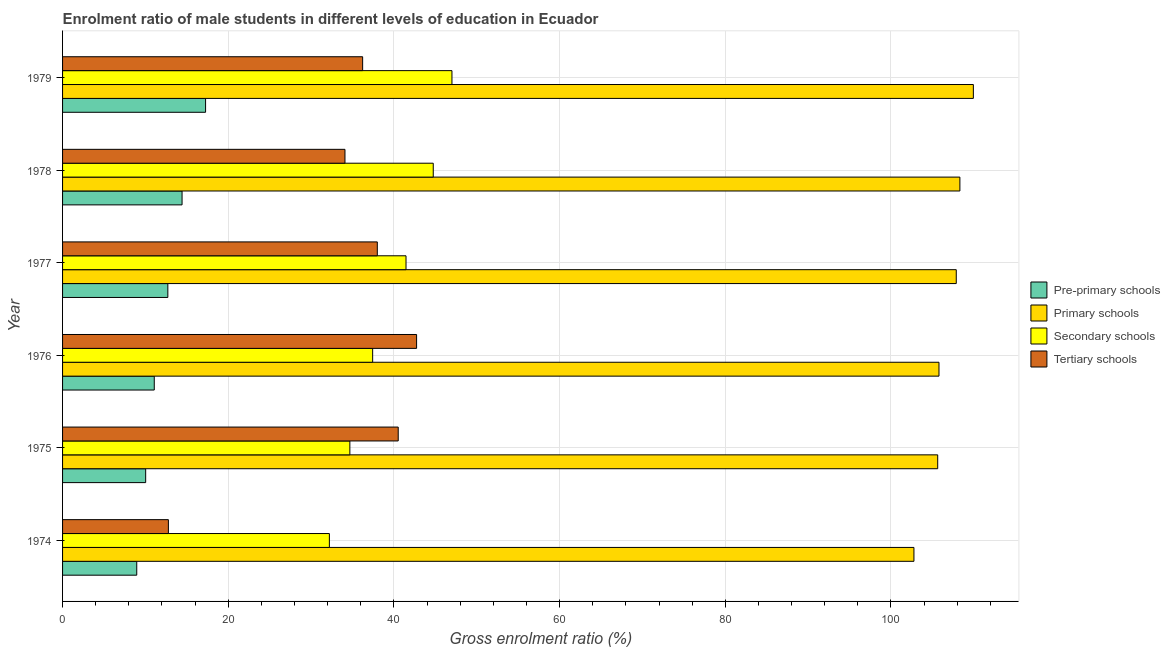How many different coloured bars are there?
Give a very brief answer. 4. How many groups of bars are there?
Provide a succinct answer. 6. Are the number of bars on each tick of the Y-axis equal?
Make the answer very short. Yes. How many bars are there on the 4th tick from the top?
Offer a terse response. 4. How many bars are there on the 6th tick from the bottom?
Your response must be concise. 4. What is the label of the 3rd group of bars from the top?
Keep it short and to the point. 1977. What is the gross enrolment ratio(female) in primary schools in 1976?
Offer a terse response. 105.8. Across all years, what is the maximum gross enrolment ratio(female) in pre-primary schools?
Provide a short and direct response. 17.27. Across all years, what is the minimum gross enrolment ratio(female) in pre-primary schools?
Make the answer very short. 8.96. In which year was the gross enrolment ratio(female) in tertiary schools maximum?
Offer a terse response. 1976. In which year was the gross enrolment ratio(female) in pre-primary schools minimum?
Provide a succinct answer. 1974. What is the total gross enrolment ratio(female) in tertiary schools in the graph?
Your answer should be very brief. 204.34. What is the difference between the gross enrolment ratio(female) in tertiary schools in 1975 and that in 1976?
Offer a terse response. -2.22. What is the difference between the gross enrolment ratio(female) in primary schools in 1978 and the gross enrolment ratio(female) in pre-primary schools in 1975?
Give a very brief answer. 98.29. What is the average gross enrolment ratio(female) in pre-primary schools per year?
Provide a succinct answer. 12.41. In the year 1974, what is the difference between the gross enrolment ratio(female) in tertiary schools and gross enrolment ratio(female) in secondary schools?
Your answer should be compact. -19.43. What is the ratio of the gross enrolment ratio(female) in tertiary schools in 1977 to that in 1978?
Give a very brief answer. 1.11. Is the difference between the gross enrolment ratio(female) in primary schools in 1977 and 1979 greater than the difference between the gross enrolment ratio(female) in tertiary schools in 1977 and 1979?
Your answer should be compact. No. What is the difference between the highest and the second highest gross enrolment ratio(female) in tertiary schools?
Make the answer very short. 2.22. What is the difference between the highest and the lowest gross enrolment ratio(female) in tertiary schools?
Your answer should be compact. 29.96. Is the sum of the gross enrolment ratio(female) in secondary schools in 1975 and 1978 greater than the maximum gross enrolment ratio(female) in pre-primary schools across all years?
Your response must be concise. Yes. What does the 2nd bar from the top in 1979 represents?
Provide a succinct answer. Secondary schools. What does the 2nd bar from the bottom in 1978 represents?
Give a very brief answer. Primary schools. Is it the case that in every year, the sum of the gross enrolment ratio(female) in pre-primary schools and gross enrolment ratio(female) in primary schools is greater than the gross enrolment ratio(female) in secondary schools?
Ensure brevity in your answer.  Yes. What is the difference between two consecutive major ticks on the X-axis?
Ensure brevity in your answer.  20. Are the values on the major ticks of X-axis written in scientific E-notation?
Offer a terse response. No. Where does the legend appear in the graph?
Provide a short and direct response. Center right. How many legend labels are there?
Your response must be concise. 4. How are the legend labels stacked?
Make the answer very short. Vertical. What is the title of the graph?
Offer a terse response. Enrolment ratio of male students in different levels of education in Ecuador. What is the label or title of the Y-axis?
Your answer should be compact. Year. What is the Gross enrolment ratio (%) in Pre-primary schools in 1974?
Your answer should be very brief. 8.96. What is the Gross enrolment ratio (%) of Primary schools in 1974?
Provide a succinct answer. 102.78. What is the Gross enrolment ratio (%) in Secondary schools in 1974?
Your answer should be very brief. 32.21. What is the Gross enrolment ratio (%) of Tertiary schools in 1974?
Keep it short and to the point. 12.77. What is the Gross enrolment ratio (%) in Pre-primary schools in 1975?
Make the answer very short. 10.03. What is the Gross enrolment ratio (%) of Primary schools in 1975?
Give a very brief answer. 105.65. What is the Gross enrolment ratio (%) of Secondary schools in 1975?
Give a very brief answer. 34.68. What is the Gross enrolment ratio (%) of Tertiary schools in 1975?
Offer a terse response. 40.52. What is the Gross enrolment ratio (%) of Pre-primary schools in 1976?
Make the answer very short. 11.07. What is the Gross enrolment ratio (%) of Primary schools in 1976?
Give a very brief answer. 105.8. What is the Gross enrolment ratio (%) in Secondary schools in 1976?
Provide a short and direct response. 37.43. What is the Gross enrolment ratio (%) in Tertiary schools in 1976?
Your response must be concise. 42.74. What is the Gross enrolment ratio (%) in Pre-primary schools in 1977?
Make the answer very short. 12.71. What is the Gross enrolment ratio (%) of Primary schools in 1977?
Offer a terse response. 107.89. What is the Gross enrolment ratio (%) of Secondary schools in 1977?
Make the answer very short. 41.46. What is the Gross enrolment ratio (%) in Tertiary schools in 1977?
Your answer should be very brief. 38. What is the Gross enrolment ratio (%) in Pre-primary schools in 1978?
Provide a succinct answer. 14.43. What is the Gross enrolment ratio (%) in Primary schools in 1978?
Give a very brief answer. 108.32. What is the Gross enrolment ratio (%) of Secondary schools in 1978?
Your answer should be compact. 44.75. What is the Gross enrolment ratio (%) of Tertiary schools in 1978?
Provide a succinct answer. 34.09. What is the Gross enrolment ratio (%) in Pre-primary schools in 1979?
Your answer should be very brief. 17.27. What is the Gross enrolment ratio (%) in Primary schools in 1979?
Give a very brief answer. 109.95. What is the Gross enrolment ratio (%) of Secondary schools in 1979?
Offer a very short reply. 47.01. What is the Gross enrolment ratio (%) of Tertiary schools in 1979?
Your answer should be compact. 36.22. Across all years, what is the maximum Gross enrolment ratio (%) in Pre-primary schools?
Your response must be concise. 17.27. Across all years, what is the maximum Gross enrolment ratio (%) of Primary schools?
Offer a terse response. 109.95. Across all years, what is the maximum Gross enrolment ratio (%) in Secondary schools?
Give a very brief answer. 47.01. Across all years, what is the maximum Gross enrolment ratio (%) in Tertiary schools?
Offer a very short reply. 42.74. Across all years, what is the minimum Gross enrolment ratio (%) of Pre-primary schools?
Make the answer very short. 8.96. Across all years, what is the minimum Gross enrolment ratio (%) in Primary schools?
Provide a succinct answer. 102.78. Across all years, what is the minimum Gross enrolment ratio (%) of Secondary schools?
Keep it short and to the point. 32.21. Across all years, what is the minimum Gross enrolment ratio (%) in Tertiary schools?
Your answer should be compact. 12.77. What is the total Gross enrolment ratio (%) of Pre-primary schools in the graph?
Provide a short and direct response. 74.46. What is the total Gross enrolment ratio (%) of Primary schools in the graph?
Make the answer very short. 640.38. What is the total Gross enrolment ratio (%) in Secondary schools in the graph?
Give a very brief answer. 237.54. What is the total Gross enrolment ratio (%) of Tertiary schools in the graph?
Give a very brief answer. 204.34. What is the difference between the Gross enrolment ratio (%) in Pre-primary schools in 1974 and that in 1975?
Make the answer very short. -1.08. What is the difference between the Gross enrolment ratio (%) in Primary schools in 1974 and that in 1975?
Provide a succinct answer. -2.87. What is the difference between the Gross enrolment ratio (%) in Secondary schools in 1974 and that in 1975?
Make the answer very short. -2.47. What is the difference between the Gross enrolment ratio (%) of Tertiary schools in 1974 and that in 1975?
Ensure brevity in your answer.  -27.75. What is the difference between the Gross enrolment ratio (%) in Pre-primary schools in 1974 and that in 1976?
Ensure brevity in your answer.  -2.11. What is the difference between the Gross enrolment ratio (%) of Primary schools in 1974 and that in 1976?
Your answer should be compact. -3.02. What is the difference between the Gross enrolment ratio (%) in Secondary schools in 1974 and that in 1976?
Provide a short and direct response. -5.22. What is the difference between the Gross enrolment ratio (%) in Tertiary schools in 1974 and that in 1976?
Make the answer very short. -29.96. What is the difference between the Gross enrolment ratio (%) in Pre-primary schools in 1974 and that in 1977?
Provide a succinct answer. -3.75. What is the difference between the Gross enrolment ratio (%) of Primary schools in 1974 and that in 1977?
Keep it short and to the point. -5.11. What is the difference between the Gross enrolment ratio (%) in Secondary schools in 1974 and that in 1977?
Your answer should be very brief. -9.25. What is the difference between the Gross enrolment ratio (%) in Tertiary schools in 1974 and that in 1977?
Offer a very short reply. -25.22. What is the difference between the Gross enrolment ratio (%) of Pre-primary schools in 1974 and that in 1978?
Offer a terse response. -5.47. What is the difference between the Gross enrolment ratio (%) in Primary schools in 1974 and that in 1978?
Offer a terse response. -5.55. What is the difference between the Gross enrolment ratio (%) in Secondary schools in 1974 and that in 1978?
Provide a short and direct response. -12.54. What is the difference between the Gross enrolment ratio (%) in Tertiary schools in 1974 and that in 1978?
Provide a succinct answer. -21.32. What is the difference between the Gross enrolment ratio (%) in Pre-primary schools in 1974 and that in 1979?
Your answer should be compact. -8.31. What is the difference between the Gross enrolment ratio (%) in Primary schools in 1974 and that in 1979?
Provide a succinct answer. -7.17. What is the difference between the Gross enrolment ratio (%) in Secondary schools in 1974 and that in 1979?
Keep it short and to the point. -14.8. What is the difference between the Gross enrolment ratio (%) in Tertiary schools in 1974 and that in 1979?
Make the answer very short. -23.45. What is the difference between the Gross enrolment ratio (%) in Pre-primary schools in 1975 and that in 1976?
Offer a very short reply. -1.04. What is the difference between the Gross enrolment ratio (%) in Primary schools in 1975 and that in 1976?
Your answer should be very brief. -0.15. What is the difference between the Gross enrolment ratio (%) of Secondary schools in 1975 and that in 1976?
Ensure brevity in your answer.  -2.75. What is the difference between the Gross enrolment ratio (%) in Tertiary schools in 1975 and that in 1976?
Offer a very short reply. -2.22. What is the difference between the Gross enrolment ratio (%) in Pre-primary schools in 1975 and that in 1977?
Make the answer very short. -2.68. What is the difference between the Gross enrolment ratio (%) in Primary schools in 1975 and that in 1977?
Your answer should be compact. -2.24. What is the difference between the Gross enrolment ratio (%) of Secondary schools in 1975 and that in 1977?
Offer a very short reply. -6.78. What is the difference between the Gross enrolment ratio (%) in Tertiary schools in 1975 and that in 1977?
Make the answer very short. 2.52. What is the difference between the Gross enrolment ratio (%) of Pre-primary schools in 1975 and that in 1978?
Your response must be concise. -4.39. What is the difference between the Gross enrolment ratio (%) in Primary schools in 1975 and that in 1978?
Your answer should be compact. -2.68. What is the difference between the Gross enrolment ratio (%) in Secondary schools in 1975 and that in 1978?
Provide a short and direct response. -10.07. What is the difference between the Gross enrolment ratio (%) in Tertiary schools in 1975 and that in 1978?
Ensure brevity in your answer.  6.43. What is the difference between the Gross enrolment ratio (%) in Pre-primary schools in 1975 and that in 1979?
Keep it short and to the point. -7.23. What is the difference between the Gross enrolment ratio (%) in Primary schools in 1975 and that in 1979?
Keep it short and to the point. -4.3. What is the difference between the Gross enrolment ratio (%) of Secondary schools in 1975 and that in 1979?
Make the answer very short. -12.32. What is the difference between the Gross enrolment ratio (%) in Tertiary schools in 1975 and that in 1979?
Give a very brief answer. 4.3. What is the difference between the Gross enrolment ratio (%) of Pre-primary schools in 1976 and that in 1977?
Keep it short and to the point. -1.64. What is the difference between the Gross enrolment ratio (%) in Primary schools in 1976 and that in 1977?
Offer a terse response. -2.09. What is the difference between the Gross enrolment ratio (%) of Secondary schools in 1976 and that in 1977?
Provide a short and direct response. -4.03. What is the difference between the Gross enrolment ratio (%) of Tertiary schools in 1976 and that in 1977?
Make the answer very short. 4.74. What is the difference between the Gross enrolment ratio (%) in Pre-primary schools in 1976 and that in 1978?
Provide a succinct answer. -3.36. What is the difference between the Gross enrolment ratio (%) in Primary schools in 1976 and that in 1978?
Make the answer very short. -2.52. What is the difference between the Gross enrolment ratio (%) in Secondary schools in 1976 and that in 1978?
Offer a terse response. -7.31. What is the difference between the Gross enrolment ratio (%) in Tertiary schools in 1976 and that in 1978?
Make the answer very short. 8.65. What is the difference between the Gross enrolment ratio (%) of Pre-primary schools in 1976 and that in 1979?
Offer a very short reply. -6.2. What is the difference between the Gross enrolment ratio (%) in Primary schools in 1976 and that in 1979?
Offer a terse response. -4.15. What is the difference between the Gross enrolment ratio (%) in Secondary schools in 1976 and that in 1979?
Your response must be concise. -9.57. What is the difference between the Gross enrolment ratio (%) of Tertiary schools in 1976 and that in 1979?
Keep it short and to the point. 6.51. What is the difference between the Gross enrolment ratio (%) in Pre-primary schools in 1977 and that in 1978?
Offer a very short reply. -1.72. What is the difference between the Gross enrolment ratio (%) in Primary schools in 1977 and that in 1978?
Your answer should be very brief. -0.44. What is the difference between the Gross enrolment ratio (%) of Secondary schools in 1977 and that in 1978?
Keep it short and to the point. -3.29. What is the difference between the Gross enrolment ratio (%) of Tertiary schools in 1977 and that in 1978?
Your answer should be compact. 3.9. What is the difference between the Gross enrolment ratio (%) of Pre-primary schools in 1977 and that in 1979?
Ensure brevity in your answer.  -4.56. What is the difference between the Gross enrolment ratio (%) in Primary schools in 1977 and that in 1979?
Give a very brief answer. -2.06. What is the difference between the Gross enrolment ratio (%) of Secondary schools in 1977 and that in 1979?
Keep it short and to the point. -5.55. What is the difference between the Gross enrolment ratio (%) of Tertiary schools in 1977 and that in 1979?
Keep it short and to the point. 1.77. What is the difference between the Gross enrolment ratio (%) of Pre-primary schools in 1978 and that in 1979?
Your answer should be very brief. -2.84. What is the difference between the Gross enrolment ratio (%) of Primary schools in 1978 and that in 1979?
Your response must be concise. -1.62. What is the difference between the Gross enrolment ratio (%) of Secondary schools in 1978 and that in 1979?
Your answer should be very brief. -2.26. What is the difference between the Gross enrolment ratio (%) of Tertiary schools in 1978 and that in 1979?
Your response must be concise. -2.13. What is the difference between the Gross enrolment ratio (%) in Pre-primary schools in 1974 and the Gross enrolment ratio (%) in Primary schools in 1975?
Your response must be concise. -96.69. What is the difference between the Gross enrolment ratio (%) of Pre-primary schools in 1974 and the Gross enrolment ratio (%) of Secondary schools in 1975?
Offer a terse response. -25.73. What is the difference between the Gross enrolment ratio (%) of Pre-primary schools in 1974 and the Gross enrolment ratio (%) of Tertiary schools in 1975?
Ensure brevity in your answer.  -31.56. What is the difference between the Gross enrolment ratio (%) of Primary schools in 1974 and the Gross enrolment ratio (%) of Secondary schools in 1975?
Your response must be concise. 68.09. What is the difference between the Gross enrolment ratio (%) of Primary schools in 1974 and the Gross enrolment ratio (%) of Tertiary schools in 1975?
Ensure brevity in your answer.  62.26. What is the difference between the Gross enrolment ratio (%) in Secondary schools in 1974 and the Gross enrolment ratio (%) in Tertiary schools in 1975?
Keep it short and to the point. -8.31. What is the difference between the Gross enrolment ratio (%) in Pre-primary schools in 1974 and the Gross enrolment ratio (%) in Primary schools in 1976?
Your answer should be compact. -96.84. What is the difference between the Gross enrolment ratio (%) of Pre-primary schools in 1974 and the Gross enrolment ratio (%) of Secondary schools in 1976?
Your answer should be compact. -28.48. What is the difference between the Gross enrolment ratio (%) of Pre-primary schools in 1974 and the Gross enrolment ratio (%) of Tertiary schools in 1976?
Make the answer very short. -33.78. What is the difference between the Gross enrolment ratio (%) in Primary schools in 1974 and the Gross enrolment ratio (%) in Secondary schools in 1976?
Make the answer very short. 65.34. What is the difference between the Gross enrolment ratio (%) of Primary schools in 1974 and the Gross enrolment ratio (%) of Tertiary schools in 1976?
Offer a terse response. 60.04. What is the difference between the Gross enrolment ratio (%) of Secondary schools in 1974 and the Gross enrolment ratio (%) of Tertiary schools in 1976?
Provide a succinct answer. -10.53. What is the difference between the Gross enrolment ratio (%) in Pre-primary schools in 1974 and the Gross enrolment ratio (%) in Primary schools in 1977?
Offer a very short reply. -98.93. What is the difference between the Gross enrolment ratio (%) in Pre-primary schools in 1974 and the Gross enrolment ratio (%) in Secondary schools in 1977?
Your answer should be very brief. -32.51. What is the difference between the Gross enrolment ratio (%) in Pre-primary schools in 1974 and the Gross enrolment ratio (%) in Tertiary schools in 1977?
Your response must be concise. -29.04. What is the difference between the Gross enrolment ratio (%) of Primary schools in 1974 and the Gross enrolment ratio (%) of Secondary schools in 1977?
Offer a terse response. 61.32. What is the difference between the Gross enrolment ratio (%) in Primary schools in 1974 and the Gross enrolment ratio (%) in Tertiary schools in 1977?
Your answer should be compact. 64.78. What is the difference between the Gross enrolment ratio (%) of Secondary schools in 1974 and the Gross enrolment ratio (%) of Tertiary schools in 1977?
Provide a succinct answer. -5.79. What is the difference between the Gross enrolment ratio (%) of Pre-primary schools in 1974 and the Gross enrolment ratio (%) of Primary schools in 1978?
Give a very brief answer. -99.37. What is the difference between the Gross enrolment ratio (%) in Pre-primary schools in 1974 and the Gross enrolment ratio (%) in Secondary schools in 1978?
Make the answer very short. -35.79. What is the difference between the Gross enrolment ratio (%) of Pre-primary schools in 1974 and the Gross enrolment ratio (%) of Tertiary schools in 1978?
Ensure brevity in your answer.  -25.14. What is the difference between the Gross enrolment ratio (%) in Primary schools in 1974 and the Gross enrolment ratio (%) in Secondary schools in 1978?
Your response must be concise. 58.03. What is the difference between the Gross enrolment ratio (%) in Primary schools in 1974 and the Gross enrolment ratio (%) in Tertiary schools in 1978?
Provide a succinct answer. 68.69. What is the difference between the Gross enrolment ratio (%) of Secondary schools in 1974 and the Gross enrolment ratio (%) of Tertiary schools in 1978?
Offer a terse response. -1.88. What is the difference between the Gross enrolment ratio (%) of Pre-primary schools in 1974 and the Gross enrolment ratio (%) of Primary schools in 1979?
Your answer should be very brief. -100.99. What is the difference between the Gross enrolment ratio (%) in Pre-primary schools in 1974 and the Gross enrolment ratio (%) in Secondary schools in 1979?
Make the answer very short. -38.05. What is the difference between the Gross enrolment ratio (%) of Pre-primary schools in 1974 and the Gross enrolment ratio (%) of Tertiary schools in 1979?
Keep it short and to the point. -27.27. What is the difference between the Gross enrolment ratio (%) in Primary schools in 1974 and the Gross enrolment ratio (%) in Secondary schools in 1979?
Ensure brevity in your answer.  55.77. What is the difference between the Gross enrolment ratio (%) in Primary schools in 1974 and the Gross enrolment ratio (%) in Tertiary schools in 1979?
Your answer should be compact. 66.55. What is the difference between the Gross enrolment ratio (%) in Secondary schools in 1974 and the Gross enrolment ratio (%) in Tertiary schools in 1979?
Offer a very short reply. -4.01. What is the difference between the Gross enrolment ratio (%) in Pre-primary schools in 1975 and the Gross enrolment ratio (%) in Primary schools in 1976?
Offer a terse response. -95.77. What is the difference between the Gross enrolment ratio (%) in Pre-primary schools in 1975 and the Gross enrolment ratio (%) in Secondary schools in 1976?
Make the answer very short. -27.4. What is the difference between the Gross enrolment ratio (%) in Pre-primary schools in 1975 and the Gross enrolment ratio (%) in Tertiary schools in 1976?
Offer a very short reply. -32.71. What is the difference between the Gross enrolment ratio (%) in Primary schools in 1975 and the Gross enrolment ratio (%) in Secondary schools in 1976?
Keep it short and to the point. 68.21. What is the difference between the Gross enrolment ratio (%) of Primary schools in 1975 and the Gross enrolment ratio (%) of Tertiary schools in 1976?
Offer a terse response. 62.91. What is the difference between the Gross enrolment ratio (%) in Secondary schools in 1975 and the Gross enrolment ratio (%) in Tertiary schools in 1976?
Offer a terse response. -8.06. What is the difference between the Gross enrolment ratio (%) in Pre-primary schools in 1975 and the Gross enrolment ratio (%) in Primary schools in 1977?
Offer a very short reply. -97.85. What is the difference between the Gross enrolment ratio (%) in Pre-primary schools in 1975 and the Gross enrolment ratio (%) in Secondary schools in 1977?
Your answer should be very brief. -31.43. What is the difference between the Gross enrolment ratio (%) in Pre-primary schools in 1975 and the Gross enrolment ratio (%) in Tertiary schools in 1977?
Provide a succinct answer. -27.96. What is the difference between the Gross enrolment ratio (%) of Primary schools in 1975 and the Gross enrolment ratio (%) of Secondary schools in 1977?
Keep it short and to the point. 64.18. What is the difference between the Gross enrolment ratio (%) of Primary schools in 1975 and the Gross enrolment ratio (%) of Tertiary schools in 1977?
Your answer should be compact. 67.65. What is the difference between the Gross enrolment ratio (%) in Secondary schools in 1975 and the Gross enrolment ratio (%) in Tertiary schools in 1977?
Keep it short and to the point. -3.31. What is the difference between the Gross enrolment ratio (%) of Pre-primary schools in 1975 and the Gross enrolment ratio (%) of Primary schools in 1978?
Offer a terse response. -98.29. What is the difference between the Gross enrolment ratio (%) in Pre-primary schools in 1975 and the Gross enrolment ratio (%) in Secondary schools in 1978?
Your answer should be very brief. -34.72. What is the difference between the Gross enrolment ratio (%) in Pre-primary schools in 1975 and the Gross enrolment ratio (%) in Tertiary schools in 1978?
Give a very brief answer. -24.06. What is the difference between the Gross enrolment ratio (%) of Primary schools in 1975 and the Gross enrolment ratio (%) of Secondary schools in 1978?
Your response must be concise. 60.9. What is the difference between the Gross enrolment ratio (%) of Primary schools in 1975 and the Gross enrolment ratio (%) of Tertiary schools in 1978?
Your response must be concise. 71.55. What is the difference between the Gross enrolment ratio (%) in Secondary schools in 1975 and the Gross enrolment ratio (%) in Tertiary schools in 1978?
Your answer should be compact. 0.59. What is the difference between the Gross enrolment ratio (%) of Pre-primary schools in 1975 and the Gross enrolment ratio (%) of Primary schools in 1979?
Your answer should be very brief. -99.92. What is the difference between the Gross enrolment ratio (%) in Pre-primary schools in 1975 and the Gross enrolment ratio (%) in Secondary schools in 1979?
Provide a succinct answer. -36.97. What is the difference between the Gross enrolment ratio (%) in Pre-primary schools in 1975 and the Gross enrolment ratio (%) in Tertiary schools in 1979?
Your answer should be very brief. -26.19. What is the difference between the Gross enrolment ratio (%) in Primary schools in 1975 and the Gross enrolment ratio (%) in Secondary schools in 1979?
Provide a succinct answer. 58.64. What is the difference between the Gross enrolment ratio (%) in Primary schools in 1975 and the Gross enrolment ratio (%) in Tertiary schools in 1979?
Keep it short and to the point. 69.42. What is the difference between the Gross enrolment ratio (%) of Secondary schools in 1975 and the Gross enrolment ratio (%) of Tertiary schools in 1979?
Make the answer very short. -1.54. What is the difference between the Gross enrolment ratio (%) in Pre-primary schools in 1976 and the Gross enrolment ratio (%) in Primary schools in 1977?
Offer a terse response. -96.82. What is the difference between the Gross enrolment ratio (%) of Pre-primary schools in 1976 and the Gross enrolment ratio (%) of Secondary schools in 1977?
Your response must be concise. -30.39. What is the difference between the Gross enrolment ratio (%) in Pre-primary schools in 1976 and the Gross enrolment ratio (%) in Tertiary schools in 1977?
Your answer should be very brief. -26.93. What is the difference between the Gross enrolment ratio (%) of Primary schools in 1976 and the Gross enrolment ratio (%) of Secondary schools in 1977?
Give a very brief answer. 64.34. What is the difference between the Gross enrolment ratio (%) of Primary schools in 1976 and the Gross enrolment ratio (%) of Tertiary schools in 1977?
Offer a very short reply. 67.8. What is the difference between the Gross enrolment ratio (%) of Secondary schools in 1976 and the Gross enrolment ratio (%) of Tertiary schools in 1977?
Keep it short and to the point. -0.56. What is the difference between the Gross enrolment ratio (%) in Pre-primary schools in 1976 and the Gross enrolment ratio (%) in Primary schools in 1978?
Provide a short and direct response. -97.26. What is the difference between the Gross enrolment ratio (%) in Pre-primary schools in 1976 and the Gross enrolment ratio (%) in Secondary schools in 1978?
Offer a very short reply. -33.68. What is the difference between the Gross enrolment ratio (%) of Pre-primary schools in 1976 and the Gross enrolment ratio (%) of Tertiary schools in 1978?
Provide a short and direct response. -23.02. What is the difference between the Gross enrolment ratio (%) of Primary schools in 1976 and the Gross enrolment ratio (%) of Secondary schools in 1978?
Give a very brief answer. 61.05. What is the difference between the Gross enrolment ratio (%) in Primary schools in 1976 and the Gross enrolment ratio (%) in Tertiary schools in 1978?
Your response must be concise. 71.71. What is the difference between the Gross enrolment ratio (%) in Secondary schools in 1976 and the Gross enrolment ratio (%) in Tertiary schools in 1978?
Keep it short and to the point. 3.34. What is the difference between the Gross enrolment ratio (%) in Pre-primary schools in 1976 and the Gross enrolment ratio (%) in Primary schools in 1979?
Give a very brief answer. -98.88. What is the difference between the Gross enrolment ratio (%) of Pre-primary schools in 1976 and the Gross enrolment ratio (%) of Secondary schools in 1979?
Provide a short and direct response. -35.94. What is the difference between the Gross enrolment ratio (%) in Pre-primary schools in 1976 and the Gross enrolment ratio (%) in Tertiary schools in 1979?
Provide a succinct answer. -25.15. What is the difference between the Gross enrolment ratio (%) in Primary schools in 1976 and the Gross enrolment ratio (%) in Secondary schools in 1979?
Provide a short and direct response. 58.79. What is the difference between the Gross enrolment ratio (%) in Primary schools in 1976 and the Gross enrolment ratio (%) in Tertiary schools in 1979?
Your response must be concise. 69.58. What is the difference between the Gross enrolment ratio (%) of Secondary schools in 1976 and the Gross enrolment ratio (%) of Tertiary schools in 1979?
Your response must be concise. 1.21. What is the difference between the Gross enrolment ratio (%) of Pre-primary schools in 1977 and the Gross enrolment ratio (%) of Primary schools in 1978?
Your answer should be compact. -95.62. What is the difference between the Gross enrolment ratio (%) in Pre-primary schools in 1977 and the Gross enrolment ratio (%) in Secondary schools in 1978?
Your answer should be compact. -32.04. What is the difference between the Gross enrolment ratio (%) of Pre-primary schools in 1977 and the Gross enrolment ratio (%) of Tertiary schools in 1978?
Your answer should be compact. -21.38. What is the difference between the Gross enrolment ratio (%) in Primary schools in 1977 and the Gross enrolment ratio (%) in Secondary schools in 1978?
Provide a succinct answer. 63.14. What is the difference between the Gross enrolment ratio (%) of Primary schools in 1977 and the Gross enrolment ratio (%) of Tertiary schools in 1978?
Offer a terse response. 73.8. What is the difference between the Gross enrolment ratio (%) of Secondary schools in 1977 and the Gross enrolment ratio (%) of Tertiary schools in 1978?
Offer a very short reply. 7.37. What is the difference between the Gross enrolment ratio (%) of Pre-primary schools in 1977 and the Gross enrolment ratio (%) of Primary schools in 1979?
Your response must be concise. -97.24. What is the difference between the Gross enrolment ratio (%) of Pre-primary schools in 1977 and the Gross enrolment ratio (%) of Secondary schools in 1979?
Ensure brevity in your answer.  -34.3. What is the difference between the Gross enrolment ratio (%) in Pre-primary schools in 1977 and the Gross enrolment ratio (%) in Tertiary schools in 1979?
Your answer should be compact. -23.51. What is the difference between the Gross enrolment ratio (%) of Primary schools in 1977 and the Gross enrolment ratio (%) of Secondary schools in 1979?
Offer a terse response. 60.88. What is the difference between the Gross enrolment ratio (%) of Primary schools in 1977 and the Gross enrolment ratio (%) of Tertiary schools in 1979?
Offer a terse response. 71.66. What is the difference between the Gross enrolment ratio (%) in Secondary schools in 1977 and the Gross enrolment ratio (%) in Tertiary schools in 1979?
Keep it short and to the point. 5.24. What is the difference between the Gross enrolment ratio (%) in Pre-primary schools in 1978 and the Gross enrolment ratio (%) in Primary schools in 1979?
Ensure brevity in your answer.  -95.52. What is the difference between the Gross enrolment ratio (%) of Pre-primary schools in 1978 and the Gross enrolment ratio (%) of Secondary schools in 1979?
Your answer should be very brief. -32.58. What is the difference between the Gross enrolment ratio (%) of Pre-primary schools in 1978 and the Gross enrolment ratio (%) of Tertiary schools in 1979?
Make the answer very short. -21.8. What is the difference between the Gross enrolment ratio (%) of Primary schools in 1978 and the Gross enrolment ratio (%) of Secondary schools in 1979?
Ensure brevity in your answer.  61.32. What is the difference between the Gross enrolment ratio (%) in Primary schools in 1978 and the Gross enrolment ratio (%) in Tertiary schools in 1979?
Offer a very short reply. 72.1. What is the difference between the Gross enrolment ratio (%) in Secondary schools in 1978 and the Gross enrolment ratio (%) in Tertiary schools in 1979?
Ensure brevity in your answer.  8.52. What is the average Gross enrolment ratio (%) of Pre-primary schools per year?
Your answer should be very brief. 12.41. What is the average Gross enrolment ratio (%) of Primary schools per year?
Provide a succinct answer. 106.73. What is the average Gross enrolment ratio (%) in Secondary schools per year?
Give a very brief answer. 39.59. What is the average Gross enrolment ratio (%) of Tertiary schools per year?
Provide a short and direct response. 34.06. In the year 1974, what is the difference between the Gross enrolment ratio (%) in Pre-primary schools and Gross enrolment ratio (%) in Primary schools?
Offer a very short reply. -93.82. In the year 1974, what is the difference between the Gross enrolment ratio (%) in Pre-primary schools and Gross enrolment ratio (%) in Secondary schools?
Provide a succinct answer. -23.25. In the year 1974, what is the difference between the Gross enrolment ratio (%) of Pre-primary schools and Gross enrolment ratio (%) of Tertiary schools?
Provide a succinct answer. -3.82. In the year 1974, what is the difference between the Gross enrolment ratio (%) in Primary schools and Gross enrolment ratio (%) in Secondary schools?
Ensure brevity in your answer.  70.57. In the year 1974, what is the difference between the Gross enrolment ratio (%) in Primary schools and Gross enrolment ratio (%) in Tertiary schools?
Keep it short and to the point. 90. In the year 1974, what is the difference between the Gross enrolment ratio (%) in Secondary schools and Gross enrolment ratio (%) in Tertiary schools?
Your answer should be very brief. 19.43. In the year 1975, what is the difference between the Gross enrolment ratio (%) of Pre-primary schools and Gross enrolment ratio (%) of Primary schools?
Make the answer very short. -95.61. In the year 1975, what is the difference between the Gross enrolment ratio (%) of Pre-primary schools and Gross enrolment ratio (%) of Secondary schools?
Ensure brevity in your answer.  -24.65. In the year 1975, what is the difference between the Gross enrolment ratio (%) in Pre-primary schools and Gross enrolment ratio (%) in Tertiary schools?
Your answer should be very brief. -30.49. In the year 1975, what is the difference between the Gross enrolment ratio (%) in Primary schools and Gross enrolment ratio (%) in Secondary schools?
Offer a terse response. 70.96. In the year 1975, what is the difference between the Gross enrolment ratio (%) in Primary schools and Gross enrolment ratio (%) in Tertiary schools?
Your answer should be compact. 65.13. In the year 1975, what is the difference between the Gross enrolment ratio (%) in Secondary schools and Gross enrolment ratio (%) in Tertiary schools?
Make the answer very short. -5.84. In the year 1976, what is the difference between the Gross enrolment ratio (%) in Pre-primary schools and Gross enrolment ratio (%) in Primary schools?
Make the answer very short. -94.73. In the year 1976, what is the difference between the Gross enrolment ratio (%) in Pre-primary schools and Gross enrolment ratio (%) in Secondary schools?
Ensure brevity in your answer.  -26.36. In the year 1976, what is the difference between the Gross enrolment ratio (%) of Pre-primary schools and Gross enrolment ratio (%) of Tertiary schools?
Offer a very short reply. -31.67. In the year 1976, what is the difference between the Gross enrolment ratio (%) in Primary schools and Gross enrolment ratio (%) in Secondary schools?
Give a very brief answer. 68.37. In the year 1976, what is the difference between the Gross enrolment ratio (%) in Primary schools and Gross enrolment ratio (%) in Tertiary schools?
Keep it short and to the point. 63.06. In the year 1976, what is the difference between the Gross enrolment ratio (%) of Secondary schools and Gross enrolment ratio (%) of Tertiary schools?
Provide a short and direct response. -5.3. In the year 1977, what is the difference between the Gross enrolment ratio (%) of Pre-primary schools and Gross enrolment ratio (%) of Primary schools?
Make the answer very short. -95.18. In the year 1977, what is the difference between the Gross enrolment ratio (%) of Pre-primary schools and Gross enrolment ratio (%) of Secondary schools?
Your answer should be compact. -28.75. In the year 1977, what is the difference between the Gross enrolment ratio (%) in Pre-primary schools and Gross enrolment ratio (%) in Tertiary schools?
Your answer should be very brief. -25.29. In the year 1977, what is the difference between the Gross enrolment ratio (%) of Primary schools and Gross enrolment ratio (%) of Secondary schools?
Your answer should be very brief. 66.43. In the year 1977, what is the difference between the Gross enrolment ratio (%) in Primary schools and Gross enrolment ratio (%) in Tertiary schools?
Offer a very short reply. 69.89. In the year 1977, what is the difference between the Gross enrolment ratio (%) of Secondary schools and Gross enrolment ratio (%) of Tertiary schools?
Offer a very short reply. 3.47. In the year 1978, what is the difference between the Gross enrolment ratio (%) of Pre-primary schools and Gross enrolment ratio (%) of Primary schools?
Your answer should be very brief. -93.9. In the year 1978, what is the difference between the Gross enrolment ratio (%) in Pre-primary schools and Gross enrolment ratio (%) in Secondary schools?
Provide a succinct answer. -30.32. In the year 1978, what is the difference between the Gross enrolment ratio (%) of Pre-primary schools and Gross enrolment ratio (%) of Tertiary schools?
Provide a short and direct response. -19.67. In the year 1978, what is the difference between the Gross enrolment ratio (%) of Primary schools and Gross enrolment ratio (%) of Secondary schools?
Make the answer very short. 63.58. In the year 1978, what is the difference between the Gross enrolment ratio (%) of Primary schools and Gross enrolment ratio (%) of Tertiary schools?
Provide a short and direct response. 74.23. In the year 1978, what is the difference between the Gross enrolment ratio (%) of Secondary schools and Gross enrolment ratio (%) of Tertiary schools?
Make the answer very short. 10.66. In the year 1979, what is the difference between the Gross enrolment ratio (%) in Pre-primary schools and Gross enrolment ratio (%) in Primary schools?
Offer a very short reply. -92.68. In the year 1979, what is the difference between the Gross enrolment ratio (%) of Pre-primary schools and Gross enrolment ratio (%) of Secondary schools?
Give a very brief answer. -29.74. In the year 1979, what is the difference between the Gross enrolment ratio (%) of Pre-primary schools and Gross enrolment ratio (%) of Tertiary schools?
Provide a succinct answer. -18.96. In the year 1979, what is the difference between the Gross enrolment ratio (%) in Primary schools and Gross enrolment ratio (%) in Secondary schools?
Your response must be concise. 62.94. In the year 1979, what is the difference between the Gross enrolment ratio (%) of Primary schools and Gross enrolment ratio (%) of Tertiary schools?
Provide a succinct answer. 73.73. In the year 1979, what is the difference between the Gross enrolment ratio (%) of Secondary schools and Gross enrolment ratio (%) of Tertiary schools?
Offer a very short reply. 10.78. What is the ratio of the Gross enrolment ratio (%) of Pre-primary schools in 1974 to that in 1975?
Make the answer very short. 0.89. What is the ratio of the Gross enrolment ratio (%) of Primary schools in 1974 to that in 1975?
Make the answer very short. 0.97. What is the ratio of the Gross enrolment ratio (%) in Secondary schools in 1974 to that in 1975?
Make the answer very short. 0.93. What is the ratio of the Gross enrolment ratio (%) of Tertiary schools in 1974 to that in 1975?
Your answer should be compact. 0.32. What is the ratio of the Gross enrolment ratio (%) of Pre-primary schools in 1974 to that in 1976?
Provide a short and direct response. 0.81. What is the ratio of the Gross enrolment ratio (%) of Primary schools in 1974 to that in 1976?
Offer a terse response. 0.97. What is the ratio of the Gross enrolment ratio (%) of Secondary schools in 1974 to that in 1976?
Make the answer very short. 0.86. What is the ratio of the Gross enrolment ratio (%) in Tertiary schools in 1974 to that in 1976?
Make the answer very short. 0.3. What is the ratio of the Gross enrolment ratio (%) in Pre-primary schools in 1974 to that in 1977?
Provide a succinct answer. 0.7. What is the ratio of the Gross enrolment ratio (%) of Primary schools in 1974 to that in 1977?
Ensure brevity in your answer.  0.95. What is the ratio of the Gross enrolment ratio (%) of Secondary schools in 1974 to that in 1977?
Give a very brief answer. 0.78. What is the ratio of the Gross enrolment ratio (%) of Tertiary schools in 1974 to that in 1977?
Ensure brevity in your answer.  0.34. What is the ratio of the Gross enrolment ratio (%) of Pre-primary schools in 1974 to that in 1978?
Offer a terse response. 0.62. What is the ratio of the Gross enrolment ratio (%) of Primary schools in 1974 to that in 1978?
Your answer should be compact. 0.95. What is the ratio of the Gross enrolment ratio (%) in Secondary schools in 1974 to that in 1978?
Keep it short and to the point. 0.72. What is the ratio of the Gross enrolment ratio (%) of Tertiary schools in 1974 to that in 1978?
Provide a short and direct response. 0.37. What is the ratio of the Gross enrolment ratio (%) in Pre-primary schools in 1974 to that in 1979?
Your answer should be compact. 0.52. What is the ratio of the Gross enrolment ratio (%) in Primary schools in 1974 to that in 1979?
Offer a very short reply. 0.93. What is the ratio of the Gross enrolment ratio (%) in Secondary schools in 1974 to that in 1979?
Your response must be concise. 0.69. What is the ratio of the Gross enrolment ratio (%) of Tertiary schools in 1974 to that in 1979?
Provide a short and direct response. 0.35. What is the ratio of the Gross enrolment ratio (%) of Pre-primary schools in 1975 to that in 1976?
Your answer should be very brief. 0.91. What is the ratio of the Gross enrolment ratio (%) of Secondary schools in 1975 to that in 1976?
Your response must be concise. 0.93. What is the ratio of the Gross enrolment ratio (%) in Tertiary schools in 1975 to that in 1976?
Offer a terse response. 0.95. What is the ratio of the Gross enrolment ratio (%) in Pre-primary schools in 1975 to that in 1977?
Offer a terse response. 0.79. What is the ratio of the Gross enrolment ratio (%) of Primary schools in 1975 to that in 1977?
Offer a terse response. 0.98. What is the ratio of the Gross enrolment ratio (%) of Secondary schools in 1975 to that in 1977?
Provide a short and direct response. 0.84. What is the ratio of the Gross enrolment ratio (%) in Tertiary schools in 1975 to that in 1977?
Provide a short and direct response. 1.07. What is the ratio of the Gross enrolment ratio (%) of Pre-primary schools in 1975 to that in 1978?
Make the answer very short. 0.7. What is the ratio of the Gross enrolment ratio (%) of Primary schools in 1975 to that in 1978?
Provide a short and direct response. 0.98. What is the ratio of the Gross enrolment ratio (%) of Secondary schools in 1975 to that in 1978?
Offer a terse response. 0.78. What is the ratio of the Gross enrolment ratio (%) in Tertiary schools in 1975 to that in 1978?
Provide a short and direct response. 1.19. What is the ratio of the Gross enrolment ratio (%) of Pre-primary schools in 1975 to that in 1979?
Keep it short and to the point. 0.58. What is the ratio of the Gross enrolment ratio (%) of Primary schools in 1975 to that in 1979?
Provide a short and direct response. 0.96. What is the ratio of the Gross enrolment ratio (%) in Secondary schools in 1975 to that in 1979?
Your response must be concise. 0.74. What is the ratio of the Gross enrolment ratio (%) in Tertiary schools in 1975 to that in 1979?
Your response must be concise. 1.12. What is the ratio of the Gross enrolment ratio (%) of Pre-primary schools in 1976 to that in 1977?
Keep it short and to the point. 0.87. What is the ratio of the Gross enrolment ratio (%) of Primary schools in 1976 to that in 1977?
Your answer should be compact. 0.98. What is the ratio of the Gross enrolment ratio (%) of Secondary schools in 1976 to that in 1977?
Offer a terse response. 0.9. What is the ratio of the Gross enrolment ratio (%) in Tertiary schools in 1976 to that in 1977?
Your response must be concise. 1.12. What is the ratio of the Gross enrolment ratio (%) in Pre-primary schools in 1976 to that in 1978?
Offer a very short reply. 0.77. What is the ratio of the Gross enrolment ratio (%) in Primary schools in 1976 to that in 1978?
Offer a very short reply. 0.98. What is the ratio of the Gross enrolment ratio (%) in Secondary schools in 1976 to that in 1978?
Ensure brevity in your answer.  0.84. What is the ratio of the Gross enrolment ratio (%) of Tertiary schools in 1976 to that in 1978?
Give a very brief answer. 1.25. What is the ratio of the Gross enrolment ratio (%) in Pre-primary schools in 1976 to that in 1979?
Provide a succinct answer. 0.64. What is the ratio of the Gross enrolment ratio (%) of Primary schools in 1976 to that in 1979?
Offer a terse response. 0.96. What is the ratio of the Gross enrolment ratio (%) in Secondary schools in 1976 to that in 1979?
Offer a terse response. 0.8. What is the ratio of the Gross enrolment ratio (%) of Tertiary schools in 1976 to that in 1979?
Provide a short and direct response. 1.18. What is the ratio of the Gross enrolment ratio (%) of Pre-primary schools in 1977 to that in 1978?
Provide a succinct answer. 0.88. What is the ratio of the Gross enrolment ratio (%) in Primary schools in 1977 to that in 1978?
Offer a very short reply. 1. What is the ratio of the Gross enrolment ratio (%) of Secondary schools in 1977 to that in 1978?
Provide a short and direct response. 0.93. What is the ratio of the Gross enrolment ratio (%) of Tertiary schools in 1977 to that in 1978?
Offer a very short reply. 1.11. What is the ratio of the Gross enrolment ratio (%) of Pre-primary schools in 1977 to that in 1979?
Make the answer very short. 0.74. What is the ratio of the Gross enrolment ratio (%) of Primary schools in 1977 to that in 1979?
Give a very brief answer. 0.98. What is the ratio of the Gross enrolment ratio (%) in Secondary schools in 1977 to that in 1979?
Your response must be concise. 0.88. What is the ratio of the Gross enrolment ratio (%) of Tertiary schools in 1977 to that in 1979?
Your response must be concise. 1.05. What is the ratio of the Gross enrolment ratio (%) of Pre-primary schools in 1978 to that in 1979?
Provide a succinct answer. 0.84. What is the ratio of the Gross enrolment ratio (%) in Primary schools in 1978 to that in 1979?
Make the answer very short. 0.99. What is the ratio of the Gross enrolment ratio (%) in Secondary schools in 1978 to that in 1979?
Provide a succinct answer. 0.95. What is the ratio of the Gross enrolment ratio (%) of Tertiary schools in 1978 to that in 1979?
Make the answer very short. 0.94. What is the difference between the highest and the second highest Gross enrolment ratio (%) of Pre-primary schools?
Your answer should be compact. 2.84. What is the difference between the highest and the second highest Gross enrolment ratio (%) of Primary schools?
Offer a terse response. 1.62. What is the difference between the highest and the second highest Gross enrolment ratio (%) in Secondary schools?
Keep it short and to the point. 2.26. What is the difference between the highest and the second highest Gross enrolment ratio (%) of Tertiary schools?
Make the answer very short. 2.22. What is the difference between the highest and the lowest Gross enrolment ratio (%) in Pre-primary schools?
Offer a very short reply. 8.31. What is the difference between the highest and the lowest Gross enrolment ratio (%) of Primary schools?
Give a very brief answer. 7.17. What is the difference between the highest and the lowest Gross enrolment ratio (%) of Secondary schools?
Provide a succinct answer. 14.8. What is the difference between the highest and the lowest Gross enrolment ratio (%) in Tertiary schools?
Your answer should be very brief. 29.96. 